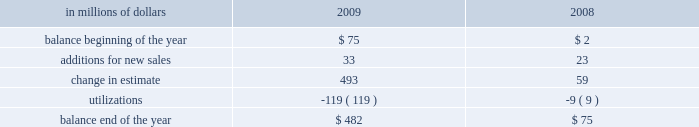Citigroup 2019s repurchases are primarily from government sponsored entities .
The specific representations and warranties made by the company depend on the nature of the transaction and the requirements of the buyer .
Market conditions and credit-ratings agency requirements may also affect representations and warranties and the other provisions the company may agree to in loan sales .
In the event of a breach of the representations and warranties , the company may be required to either repurchase the mortgage loans ( generally at unpaid principal balance plus accrued interest ) with the identified defects or indemnify ( 201cmake-whole 201d ) the investor or insurer .
The company has recorded a repurchase reserve that is included in other liabilities in the consolidated balance sheet .
In the case of a repurchase , the company will bear any subsequent credit loss on the mortgage loans .
The company 2019s representations and warranties are generally not subject to stated limits in amount or time of coverage .
However , contractual liability arises only when the representations and warranties are breached and generally only when a loss results from the breach .
In the case of a repurchase , the loan is typically considered a credit- impaired loan and accounted for under sop 03-3 , 201caccounting for certain loans and debt securities , acquired in a transfer 201d ( now incorporated into asc 310-30 , receivables 2014loans and debt securities acquired with deteriorated credit quality ) .
These repurchases have not had a material impact on nonperforming loan statistics , because credit-impaired purchased sop 03-3 loans are not included in nonaccrual loans .
The company estimates its exposure to losses from its obligation to repurchase previously sold loans based on the probability of repurchase or make-whole and an estimated loss given repurchase or make-whole .
This estimate is calculated separately by sales vintage ( i.e. , the year the loans were sold ) based on a combination of historical trends and forecasted repurchases and losses considering the : ( 1 ) trends in requests by investors for loan documentation packages to be reviewed ; ( 2 ) trends in recent repurchases and make-wholes ; ( 3 ) historical percentage of claims made as a percentage of loan documentation package requests ; ( 4 ) success rate in appealing claims ; ( 5 ) inventory of unresolved claims ; and ( 6 ) estimated loss given repurchase or make-whole , including the loss of principal , accrued interest , and foreclosure costs .
The company does not change its estimation methodology by counterparty , but the historical experience and trends are considered when evaluating the overall reserve .
The request for loan documentation packages is an early indicator of a potential claim .
During 2009 , loan documentation package requests and the level of outstanding claims increased .
In addition , our loss severity estimates increased during 2009 due to the impact of macroeconomic factors and recent experience .
These factors contributed to a $ 493 million change in estimate for this reserve in 2009 .
As indicated above , the repurchase reserve is calculated by sales vintage .
The majority of the repurchases in 2009 were from the 2006 and 2007 sales vintages , which also represent the vintages with the largest loss- given-repurchase .
An insignificant percentage of 2009 repurchases were from vintages prior to 2006 , and this is expected to decrease , because those vintages are later in the credit cycle .
Although early in the credit cycle , the company has experienced improved repurchase and loss-given-repurchase statistics from the 2008 and 2009 vintages .
In the case of a repurchase of a credit-impaired sop 03-3 loan ( now incorporated into asc 310-30 ) , the difference between the loan 2019s fair value and unpaid principal balance at the time of the repurchase is recorded as a utilization of the repurchase reserve .
Payments to make the investor whole are also treated as utilizations and charged directly against the reserve .
The provision for estimated probable losses arising from loan sales is recorded as an adjustment to the gain on sale , which is included in other revenue in the consolidated statement of income .
A liability for representations and warranties is estimated when the company sells loans and is updated quarterly .
Any subsequent adjustment to the provision is recorded in other revenue in the consolidated statement of income .
The activity in the repurchase reserve for the years ended december 31 , 2009 and 2008 is as follows: .
Goodwill goodwill represents an acquired company 2019s acquisition cost over the fair value of net tangible and intangible assets acquired .
Goodwill is subject to annual impairment tests , whereby goodwill is allocated to the company 2019s reporting units and an impairment is deemed to exist if the carrying value of a reporting unit exceeds its estimated fair value .
Furthermore , on any business dispositions , goodwill is allocated to the business disposed of based on the ratio of the fair value of the business disposed of to the fair value of the reporting unit .
Intangible assets intangible assets 2014including core deposit intangibles , present value of future profits , purchased credit card relationships , other customer relationships , and other intangible assets , but excluding msrs 2014are amortized over their estimated useful lives .
Intangible assets deemed to have indefinite useful lives , primarily certain asset management contracts and trade names , are not amortized and are subject to annual impairment tests .
An impairment exists if the carrying value of the indefinite-lived intangible asset exceeds its fair value .
For other intangible assets subject to amortization , an impairment is recognized if the carrying amount is not recoverable and exceeds the fair value of the intangible asset .
Other assets and other liabilities other assets include , among other items , loans held-for-sale , deferred tax assets , equity-method investments , interest and fees receivable , premises and equipment , end-user derivatives in a net receivable position , repossessed assets , and other receivables. .
What was the percentage change in the repurchase reserve between 2008 and 2009 , in millions? 
Computations: ((482 - 75) / 75)
Answer: 5.42667. 